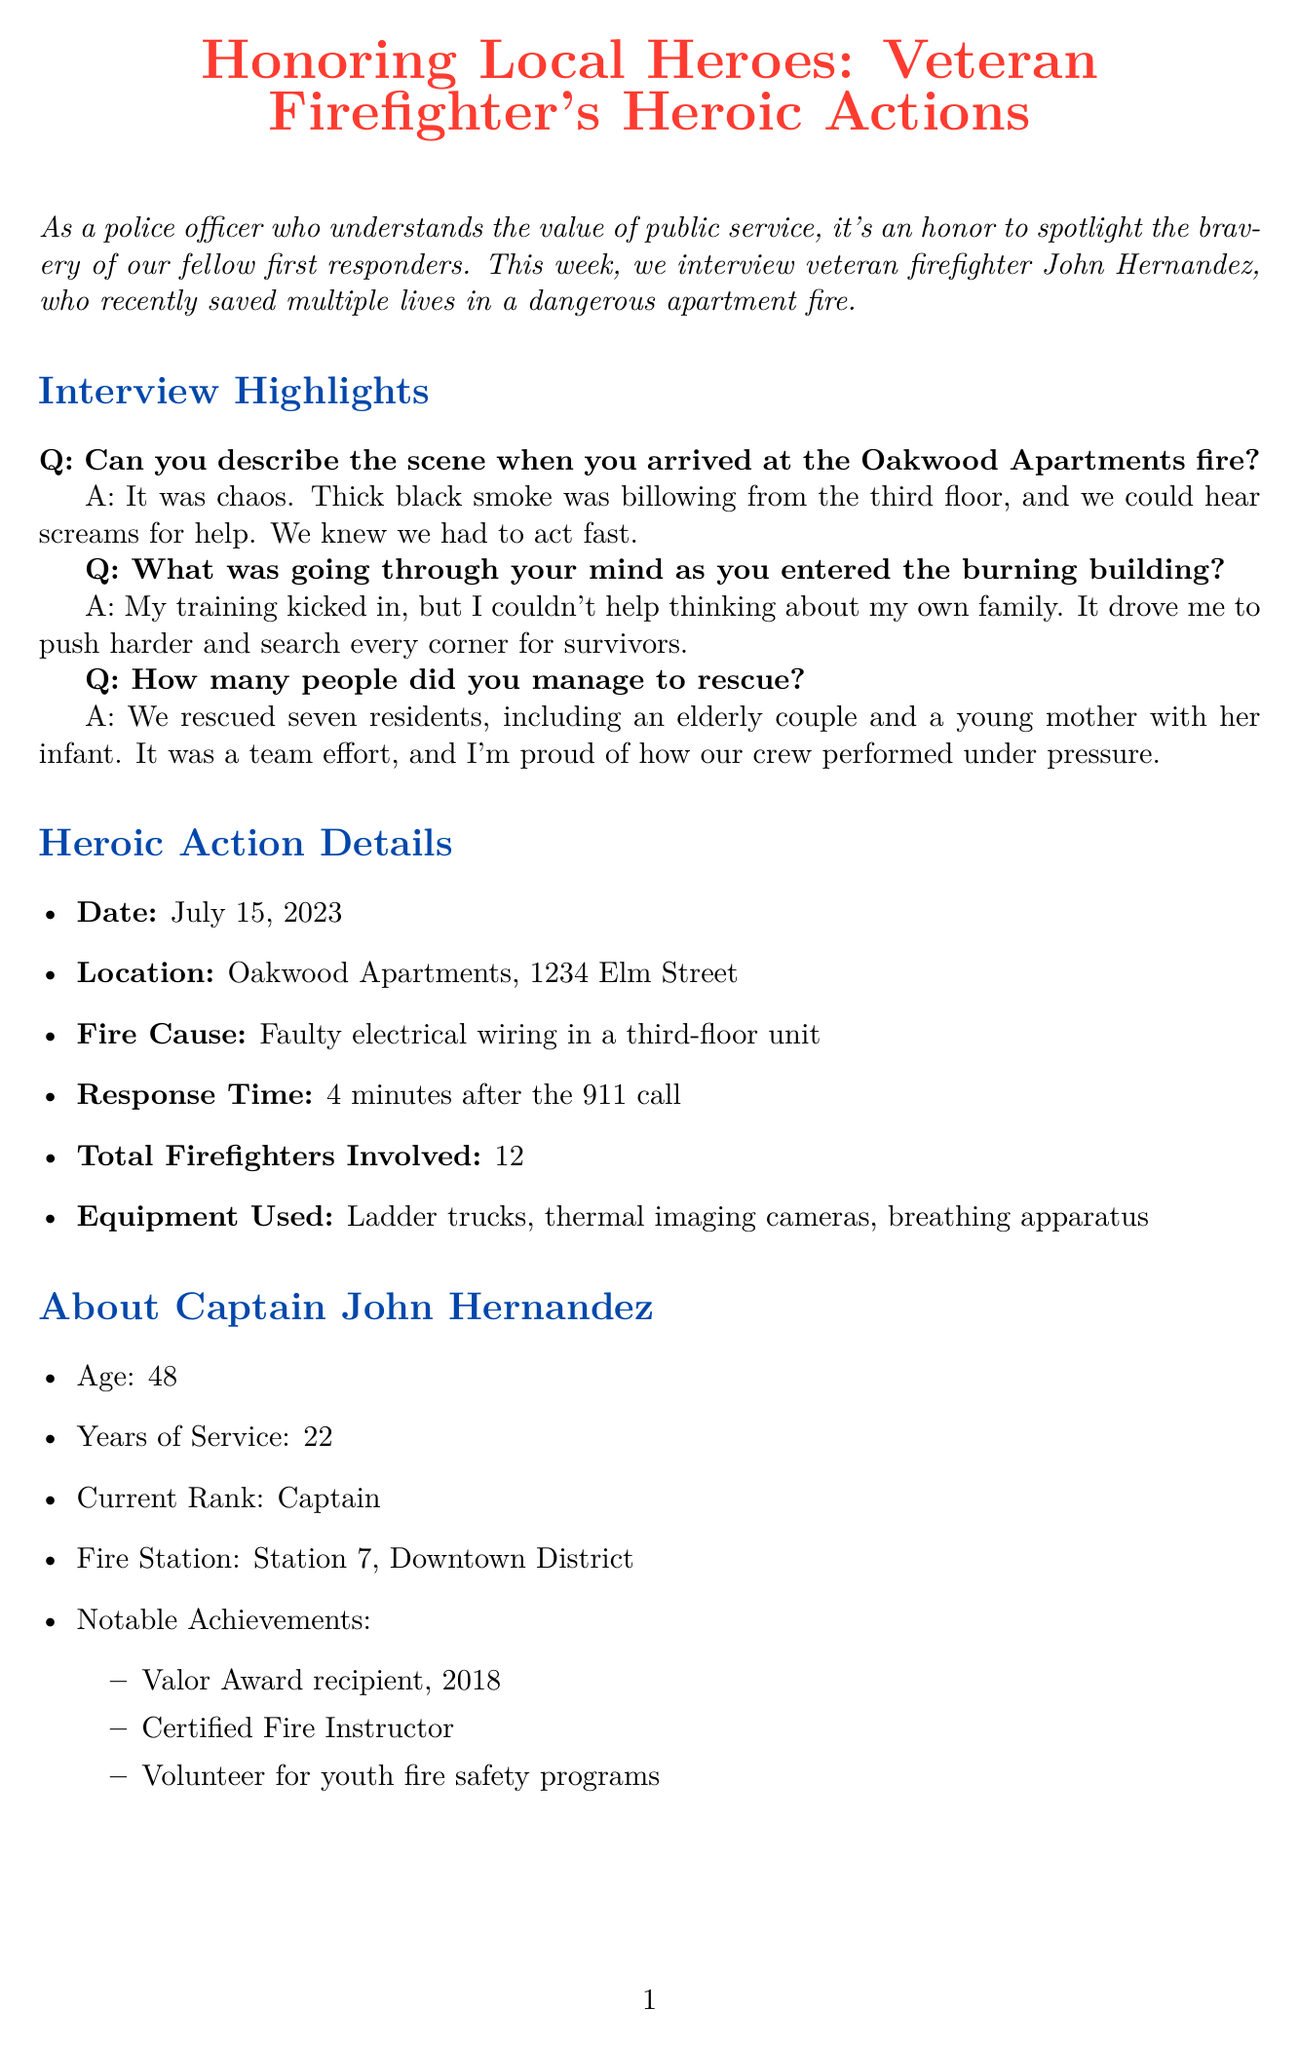Can you name the firefighter interviewed in the newsletter? The firefighter's name is mentioned in the interview section of the document.
Answer: John Hernandez What was the date of the apartment fire? The date is clearly stated in the heroic action details section of the document.
Answer: July 15, 2023 How many years of service does Captain Hernandez have? The document specifies his years of service in his background information.
Answer: 22 What was the cause of the apartment fire? The cause of the fire is detailed in the heroic action details section of the document.
Answer: Faulty electrical wiring in a third-floor unit How many residents were rescued from the fire? This information is provided in an answer during the interview highlights.
Answer: Seven What was the response time to the fire? The response time is outlined in the heroic action details section.
Answer: 4 minutes What significant recognition did Captain Hernandez receive in 2018? His notable achievements include receiving an award mentioned in his background.
Answer: Valor Award Which fire safety tip advises on cooking practices? The fire safety tips section contains advice related to cooking.
Answer: Never leave cooking unattended What community action occurred after the fire? The community response section describes actions taken in response to the fire incident.
Answer: A fundraiser for fire victims organized by local businesses 